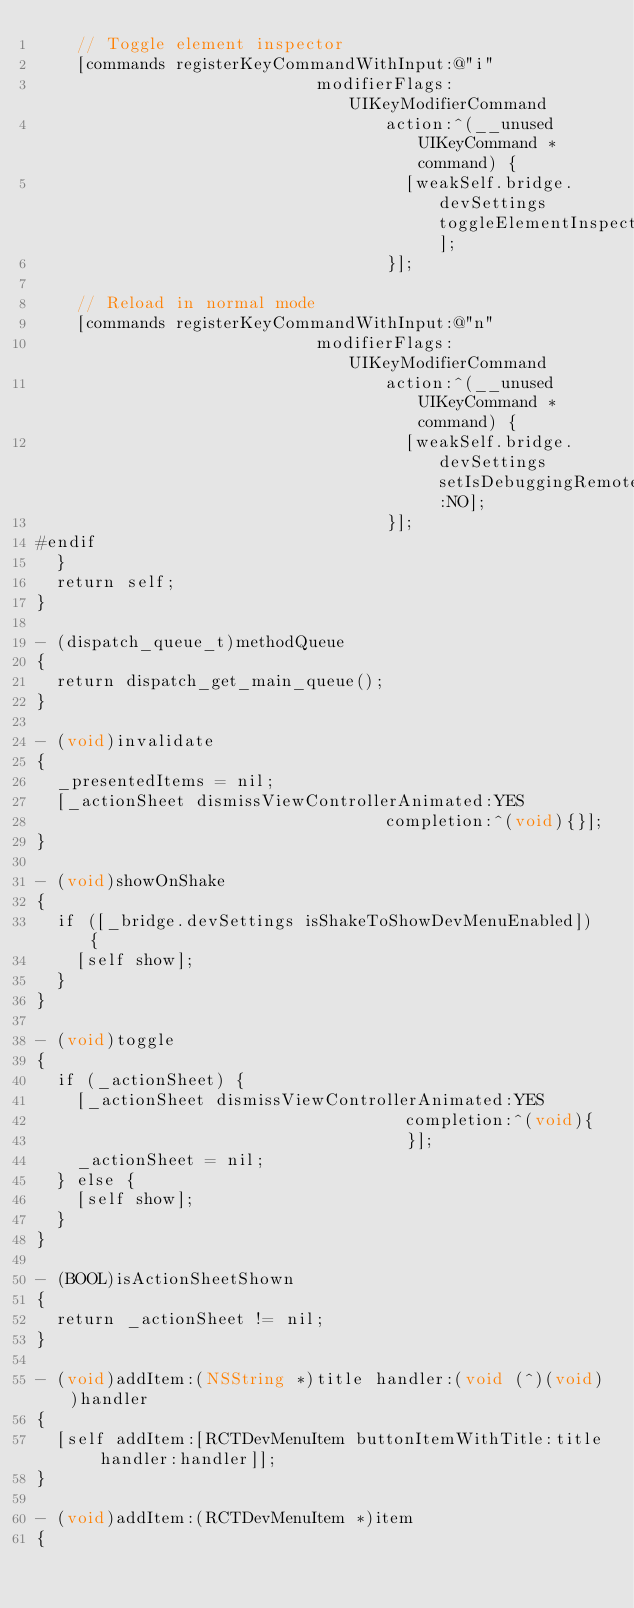<code> <loc_0><loc_0><loc_500><loc_500><_ObjectiveC_>    // Toggle element inspector
    [commands registerKeyCommandWithInput:@"i"
                            modifierFlags:UIKeyModifierCommand
                                   action:^(__unused UIKeyCommand *command) {
                                     [weakSelf.bridge.devSettings toggleElementInspector];
                                   }];

    // Reload in normal mode
    [commands registerKeyCommandWithInput:@"n"
                            modifierFlags:UIKeyModifierCommand
                                   action:^(__unused UIKeyCommand *command) {
                                     [weakSelf.bridge.devSettings setIsDebuggingRemotely:NO];
                                   }];
#endif
  }
  return self;
}

- (dispatch_queue_t)methodQueue
{
  return dispatch_get_main_queue();
}

- (void)invalidate
{
  _presentedItems = nil;
  [_actionSheet dismissViewControllerAnimated:YES
                                   completion:^(void){}];
}

- (void)showOnShake
{
  if ([_bridge.devSettings isShakeToShowDevMenuEnabled]) {
    [self show];
  }
}

- (void)toggle
{
  if (_actionSheet) {
    [_actionSheet dismissViewControllerAnimated:YES
                                     completion:^(void){
                                     }];
    _actionSheet = nil;
  } else {
    [self show];
  }
}

- (BOOL)isActionSheetShown
{
  return _actionSheet != nil;
}

- (void)addItem:(NSString *)title handler:(void (^)(void))handler
{
  [self addItem:[RCTDevMenuItem buttonItemWithTitle:title handler:handler]];
}

- (void)addItem:(RCTDevMenuItem *)item
{</code> 